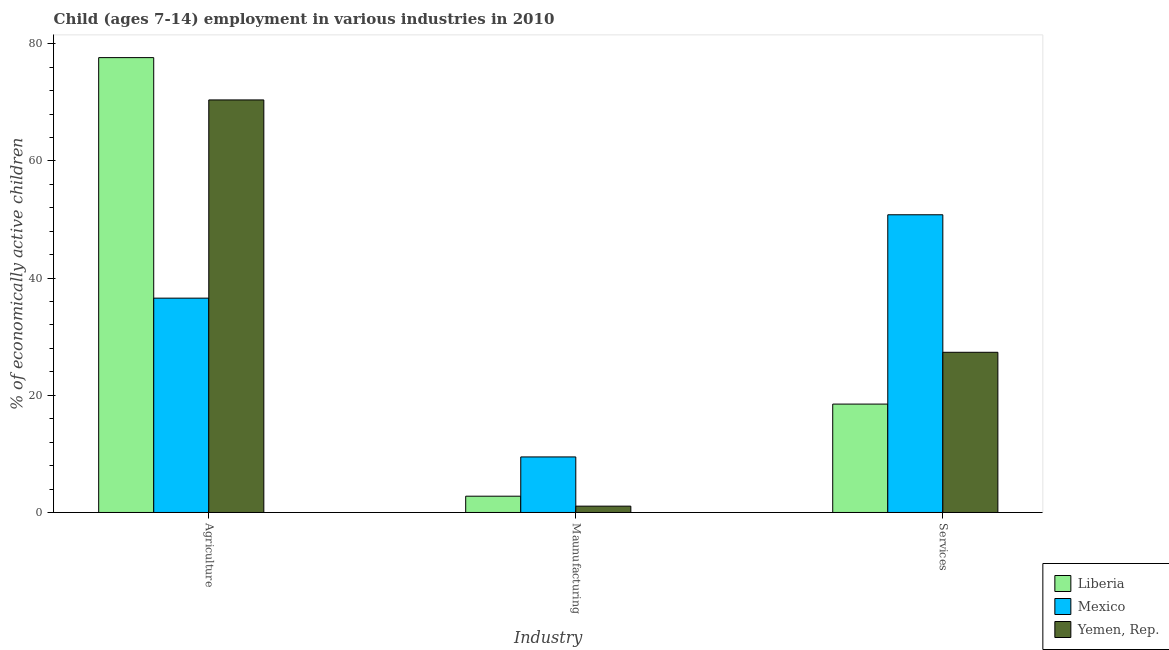How many different coloured bars are there?
Give a very brief answer. 3. Are the number of bars per tick equal to the number of legend labels?
Give a very brief answer. Yes. Are the number of bars on each tick of the X-axis equal?
Your answer should be compact. Yes. How many bars are there on the 1st tick from the right?
Keep it short and to the point. 3. What is the label of the 1st group of bars from the left?
Your answer should be very brief. Agriculture. What is the percentage of economically active children in agriculture in Liberia?
Give a very brief answer. 77.63. Across all countries, what is the maximum percentage of economically active children in agriculture?
Offer a terse response. 77.63. In which country was the percentage of economically active children in manufacturing maximum?
Offer a very short reply. Mexico. In which country was the percentage of economically active children in services minimum?
Make the answer very short. Liberia. What is the total percentage of economically active children in services in the graph?
Provide a short and direct response. 96.65. What is the difference between the percentage of economically active children in services in Liberia and that in Mexico?
Offer a very short reply. -32.31. What is the difference between the percentage of economically active children in services in Mexico and the percentage of economically active children in manufacturing in Liberia?
Give a very brief answer. 48.03. What is the average percentage of economically active children in agriculture per country?
Offer a terse response. 61.54. What is the difference between the percentage of economically active children in manufacturing and percentage of economically active children in services in Liberia?
Provide a short and direct response. -15.72. What is the ratio of the percentage of economically active children in services in Mexico to that in Yemen, Rep.?
Ensure brevity in your answer.  1.86. Is the difference between the percentage of economically active children in services in Mexico and Yemen, Rep. greater than the difference between the percentage of economically active children in agriculture in Mexico and Yemen, Rep.?
Provide a short and direct response. Yes. What is the difference between the highest and the second highest percentage of economically active children in manufacturing?
Give a very brief answer. 6.7. What does the 1st bar from the left in Maunufacturing represents?
Ensure brevity in your answer.  Liberia. What does the 2nd bar from the right in Services represents?
Offer a terse response. Mexico. Is it the case that in every country, the sum of the percentage of economically active children in agriculture and percentage of economically active children in manufacturing is greater than the percentage of economically active children in services?
Provide a short and direct response. No. How many countries are there in the graph?
Your answer should be very brief. 3. Are the values on the major ticks of Y-axis written in scientific E-notation?
Your answer should be compact. No. Where does the legend appear in the graph?
Make the answer very short. Bottom right. How many legend labels are there?
Ensure brevity in your answer.  3. How are the legend labels stacked?
Offer a terse response. Vertical. What is the title of the graph?
Offer a very short reply. Child (ages 7-14) employment in various industries in 2010. Does "Angola" appear as one of the legend labels in the graph?
Ensure brevity in your answer.  No. What is the label or title of the X-axis?
Provide a short and direct response. Industry. What is the label or title of the Y-axis?
Your response must be concise. % of economically active children. What is the % of economically active children in Liberia in Agriculture?
Make the answer very short. 77.63. What is the % of economically active children in Mexico in Agriculture?
Make the answer very short. 36.58. What is the % of economically active children of Yemen, Rep. in Agriculture?
Your response must be concise. 70.41. What is the % of economically active children of Liberia in Maunufacturing?
Your response must be concise. 2.78. What is the % of economically active children of Mexico in Maunufacturing?
Your answer should be very brief. 9.48. What is the % of economically active children of Yemen, Rep. in Maunufacturing?
Your answer should be very brief. 1.08. What is the % of economically active children of Mexico in Services?
Ensure brevity in your answer.  50.81. What is the % of economically active children of Yemen, Rep. in Services?
Your response must be concise. 27.34. Across all Industry, what is the maximum % of economically active children in Liberia?
Your response must be concise. 77.63. Across all Industry, what is the maximum % of economically active children of Mexico?
Your answer should be compact. 50.81. Across all Industry, what is the maximum % of economically active children in Yemen, Rep.?
Make the answer very short. 70.41. Across all Industry, what is the minimum % of economically active children in Liberia?
Offer a terse response. 2.78. Across all Industry, what is the minimum % of economically active children of Mexico?
Your answer should be compact. 9.48. Across all Industry, what is the minimum % of economically active children of Yemen, Rep.?
Provide a succinct answer. 1.08. What is the total % of economically active children of Liberia in the graph?
Make the answer very short. 98.91. What is the total % of economically active children in Mexico in the graph?
Keep it short and to the point. 96.87. What is the total % of economically active children in Yemen, Rep. in the graph?
Give a very brief answer. 98.83. What is the difference between the % of economically active children of Liberia in Agriculture and that in Maunufacturing?
Your answer should be very brief. 74.85. What is the difference between the % of economically active children in Mexico in Agriculture and that in Maunufacturing?
Offer a very short reply. 27.1. What is the difference between the % of economically active children of Yemen, Rep. in Agriculture and that in Maunufacturing?
Offer a very short reply. 69.33. What is the difference between the % of economically active children of Liberia in Agriculture and that in Services?
Keep it short and to the point. 59.13. What is the difference between the % of economically active children of Mexico in Agriculture and that in Services?
Provide a succinct answer. -14.23. What is the difference between the % of economically active children of Yemen, Rep. in Agriculture and that in Services?
Provide a short and direct response. 43.07. What is the difference between the % of economically active children in Liberia in Maunufacturing and that in Services?
Your answer should be compact. -15.72. What is the difference between the % of economically active children of Mexico in Maunufacturing and that in Services?
Make the answer very short. -41.33. What is the difference between the % of economically active children of Yemen, Rep. in Maunufacturing and that in Services?
Offer a terse response. -26.26. What is the difference between the % of economically active children in Liberia in Agriculture and the % of economically active children in Mexico in Maunufacturing?
Your answer should be very brief. 68.15. What is the difference between the % of economically active children of Liberia in Agriculture and the % of economically active children of Yemen, Rep. in Maunufacturing?
Offer a very short reply. 76.55. What is the difference between the % of economically active children in Mexico in Agriculture and the % of economically active children in Yemen, Rep. in Maunufacturing?
Give a very brief answer. 35.5. What is the difference between the % of economically active children of Liberia in Agriculture and the % of economically active children of Mexico in Services?
Offer a terse response. 26.82. What is the difference between the % of economically active children in Liberia in Agriculture and the % of economically active children in Yemen, Rep. in Services?
Give a very brief answer. 50.29. What is the difference between the % of economically active children in Mexico in Agriculture and the % of economically active children in Yemen, Rep. in Services?
Make the answer very short. 9.24. What is the difference between the % of economically active children in Liberia in Maunufacturing and the % of economically active children in Mexico in Services?
Your response must be concise. -48.03. What is the difference between the % of economically active children of Liberia in Maunufacturing and the % of economically active children of Yemen, Rep. in Services?
Your response must be concise. -24.56. What is the difference between the % of economically active children of Mexico in Maunufacturing and the % of economically active children of Yemen, Rep. in Services?
Your answer should be very brief. -17.86. What is the average % of economically active children in Liberia per Industry?
Give a very brief answer. 32.97. What is the average % of economically active children in Mexico per Industry?
Offer a very short reply. 32.29. What is the average % of economically active children of Yemen, Rep. per Industry?
Offer a terse response. 32.94. What is the difference between the % of economically active children in Liberia and % of economically active children in Mexico in Agriculture?
Ensure brevity in your answer.  41.05. What is the difference between the % of economically active children in Liberia and % of economically active children in Yemen, Rep. in Agriculture?
Provide a short and direct response. 7.22. What is the difference between the % of economically active children of Mexico and % of economically active children of Yemen, Rep. in Agriculture?
Give a very brief answer. -33.83. What is the difference between the % of economically active children of Liberia and % of economically active children of Mexico in Maunufacturing?
Your answer should be compact. -6.7. What is the difference between the % of economically active children in Liberia and % of economically active children in Yemen, Rep. in Maunufacturing?
Ensure brevity in your answer.  1.7. What is the difference between the % of economically active children in Liberia and % of economically active children in Mexico in Services?
Your response must be concise. -32.31. What is the difference between the % of economically active children in Liberia and % of economically active children in Yemen, Rep. in Services?
Make the answer very short. -8.84. What is the difference between the % of economically active children of Mexico and % of economically active children of Yemen, Rep. in Services?
Provide a succinct answer. 23.47. What is the ratio of the % of economically active children in Liberia in Agriculture to that in Maunufacturing?
Offer a very short reply. 27.92. What is the ratio of the % of economically active children in Mexico in Agriculture to that in Maunufacturing?
Make the answer very short. 3.86. What is the ratio of the % of economically active children in Yemen, Rep. in Agriculture to that in Maunufacturing?
Keep it short and to the point. 65.19. What is the ratio of the % of economically active children in Liberia in Agriculture to that in Services?
Offer a very short reply. 4.2. What is the ratio of the % of economically active children in Mexico in Agriculture to that in Services?
Your answer should be compact. 0.72. What is the ratio of the % of economically active children in Yemen, Rep. in Agriculture to that in Services?
Your response must be concise. 2.58. What is the ratio of the % of economically active children in Liberia in Maunufacturing to that in Services?
Offer a very short reply. 0.15. What is the ratio of the % of economically active children of Mexico in Maunufacturing to that in Services?
Your answer should be very brief. 0.19. What is the ratio of the % of economically active children in Yemen, Rep. in Maunufacturing to that in Services?
Provide a succinct answer. 0.04. What is the difference between the highest and the second highest % of economically active children of Liberia?
Your answer should be compact. 59.13. What is the difference between the highest and the second highest % of economically active children in Mexico?
Provide a succinct answer. 14.23. What is the difference between the highest and the second highest % of economically active children in Yemen, Rep.?
Keep it short and to the point. 43.07. What is the difference between the highest and the lowest % of economically active children of Liberia?
Ensure brevity in your answer.  74.85. What is the difference between the highest and the lowest % of economically active children of Mexico?
Offer a terse response. 41.33. What is the difference between the highest and the lowest % of economically active children of Yemen, Rep.?
Provide a succinct answer. 69.33. 